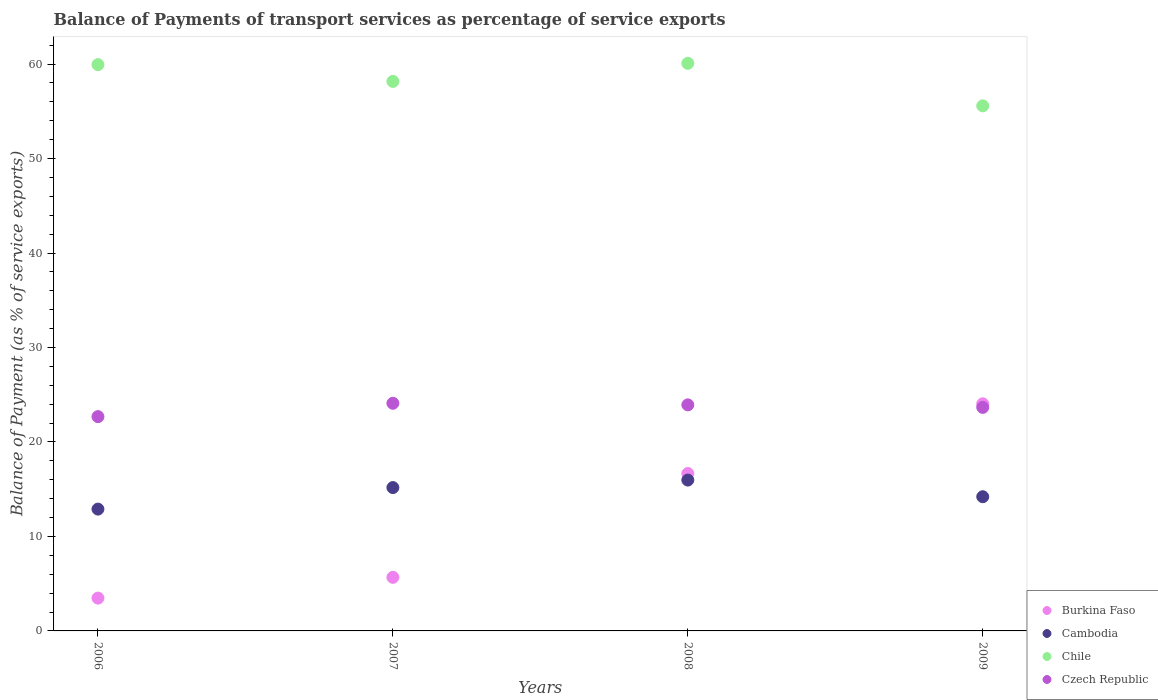What is the balance of payments of transport services in Czech Republic in 2008?
Offer a very short reply. 23.93. Across all years, what is the maximum balance of payments of transport services in Chile?
Provide a succinct answer. 60.08. Across all years, what is the minimum balance of payments of transport services in Burkina Faso?
Keep it short and to the point. 3.47. What is the total balance of payments of transport services in Czech Republic in the graph?
Give a very brief answer. 94.37. What is the difference between the balance of payments of transport services in Czech Republic in 2006 and that in 2007?
Give a very brief answer. -1.41. What is the difference between the balance of payments of transport services in Cambodia in 2006 and the balance of payments of transport services in Chile in 2008?
Keep it short and to the point. -47.19. What is the average balance of payments of transport services in Czech Republic per year?
Your response must be concise. 23.59. In the year 2009, what is the difference between the balance of payments of transport services in Czech Republic and balance of payments of transport services in Cambodia?
Your response must be concise. 9.46. In how many years, is the balance of payments of transport services in Chile greater than 56 %?
Your answer should be compact. 3. What is the ratio of the balance of payments of transport services in Burkina Faso in 2007 to that in 2008?
Keep it short and to the point. 0.34. Is the balance of payments of transport services in Chile in 2008 less than that in 2009?
Offer a very short reply. No. Is the difference between the balance of payments of transport services in Czech Republic in 2008 and 2009 greater than the difference between the balance of payments of transport services in Cambodia in 2008 and 2009?
Keep it short and to the point. No. What is the difference between the highest and the second highest balance of payments of transport services in Czech Republic?
Provide a succinct answer. 0.17. What is the difference between the highest and the lowest balance of payments of transport services in Czech Republic?
Your answer should be very brief. 1.41. In how many years, is the balance of payments of transport services in Burkina Faso greater than the average balance of payments of transport services in Burkina Faso taken over all years?
Offer a very short reply. 2. Is the sum of the balance of payments of transport services in Cambodia in 2007 and 2008 greater than the maximum balance of payments of transport services in Burkina Faso across all years?
Provide a short and direct response. Yes. Is it the case that in every year, the sum of the balance of payments of transport services in Chile and balance of payments of transport services in Czech Republic  is greater than the sum of balance of payments of transport services in Cambodia and balance of payments of transport services in Burkina Faso?
Provide a short and direct response. Yes. Does the balance of payments of transport services in Czech Republic monotonically increase over the years?
Offer a terse response. No. Is the balance of payments of transport services in Burkina Faso strictly greater than the balance of payments of transport services in Cambodia over the years?
Your answer should be very brief. No. Is the balance of payments of transport services in Burkina Faso strictly less than the balance of payments of transport services in Chile over the years?
Provide a short and direct response. Yes. How many dotlines are there?
Your answer should be compact. 4. Does the graph contain any zero values?
Provide a succinct answer. No. Does the graph contain grids?
Keep it short and to the point. No. How many legend labels are there?
Ensure brevity in your answer.  4. What is the title of the graph?
Ensure brevity in your answer.  Balance of Payments of transport services as percentage of service exports. Does "Djibouti" appear as one of the legend labels in the graph?
Make the answer very short. No. What is the label or title of the X-axis?
Offer a very short reply. Years. What is the label or title of the Y-axis?
Provide a succinct answer. Balance of Payment (as % of service exports). What is the Balance of Payment (as % of service exports) in Burkina Faso in 2006?
Your answer should be compact. 3.47. What is the Balance of Payment (as % of service exports) in Cambodia in 2006?
Your response must be concise. 12.89. What is the Balance of Payment (as % of service exports) in Chile in 2006?
Your response must be concise. 59.94. What is the Balance of Payment (as % of service exports) in Czech Republic in 2006?
Ensure brevity in your answer.  22.68. What is the Balance of Payment (as % of service exports) of Burkina Faso in 2007?
Your answer should be compact. 5.67. What is the Balance of Payment (as % of service exports) in Cambodia in 2007?
Your response must be concise. 15.17. What is the Balance of Payment (as % of service exports) of Chile in 2007?
Keep it short and to the point. 58.17. What is the Balance of Payment (as % of service exports) of Czech Republic in 2007?
Offer a terse response. 24.1. What is the Balance of Payment (as % of service exports) in Burkina Faso in 2008?
Your answer should be compact. 16.66. What is the Balance of Payment (as % of service exports) in Cambodia in 2008?
Keep it short and to the point. 15.97. What is the Balance of Payment (as % of service exports) in Chile in 2008?
Make the answer very short. 60.08. What is the Balance of Payment (as % of service exports) of Czech Republic in 2008?
Offer a terse response. 23.93. What is the Balance of Payment (as % of service exports) of Burkina Faso in 2009?
Provide a succinct answer. 24.04. What is the Balance of Payment (as % of service exports) in Cambodia in 2009?
Offer a very short reply. 14.21. What is the Balance of Payment (as % of service exports) of Chile in 2009?
Ensure brevity in your answer.  55.58. What is the Balance of Payment (as % of service exports) of Czech Republic in 2009?
Provide a short and direct response. 23.66. Across all years, what is the maximum Balance of Payment (as % of service exports) of Burkina Faso?
Ensure brevity in your answer.  24.04. Across all years, what is the maximum Balance of Payment (as % of service exports) of Cambodia?
Your answer should be compact. 15.97. Across all years, what is the maximum Balance of Payment (as % of service exports) in Chile?
Offer a very short reply. 60.08. Across all years, what is the maximum Balance of Payment (as % of service exports) of Czech Republic?
Offer a very short reply. 24.1. Across all years, what is the minimum Balance of Payment (as % of service exports) in Burkina Faso?
Offer a terse response. 3.47. Across all years, what is the minimum Balance of Payment (as % of service exports) of Cambodia?
Provide a short and direct response. 12.89. Across all years, what is the minimum Balance of Payment (as % of service exports) in Chile?
Your answer should be compact. 55.58. Across all years, what is the minimum Balance of Payment (as % of service exports) of Czech Republic?
Your response must be concise. 22.68. What is the total Balance of Payment (as % of service exports) in Burkina Faso in the graph?
Your response must be concise. 49.85. What is the total Balance of Payment (as % of service exports) in Cambodia in the graph?
Ensure brevity in your answer.  58.24. What is the total Balance of Payment (as % of service exports) in Chile in the graph?
Provide a short and direct response. 233.78. What is the total Balance of Payment (as % of service exports) of Czech Republic in the graph?
Your answer should be compact. 94.37. What is the difference between the Balance of Payment (as % of service exports) in Burkina Faso in 2006 and that in 2007?
Offer a terse response. -2.2. What is the difference between the Balance of Payment (as % of service exports) in Cambodia in 2006 and that in 2007?
Provide a short and direct response. -2.28. What is the difference between the Balance of Payment (as % of service exports) of Chile in 2006 and that in 2007?
Give a very brief answer. 1.78. What is the difference between the Balance of Payment (as % of service exports) of Czech Republic in 2006 and that in 2007?
Offer a terse response. -1.41. What is the difference between the Balance of Payment (as % of service exports) of Burkina Faso in 2006 and that in 2008?
Offer a very short reply. -13.19. What is the difference between the Balance of Payment (as % of service exports) of Cambodia in 2006 and that in 2008?
Ensure brevity in your answer.  -3.07. What is the difference between the Balance of Payment (as % of service exports) in Chile in 2006 and that in 2008?
Your response must be concise. -0.14. What is the difference between the Balance of Payment (as % of service exports) of Czech Republic in 2006 and that in 2008?
Your response must be concise. -1.24. What is the difference between the Balance of Payment (as % of service exports) of Burkina Faso in 2006 and that in 2009?
Ensure brevity in your answer.  -20.57. What is the difference between the Balance of Payment (as % of service exports) of Cambodia in 2006 and that in 2009?
Offer a terse response. -1.31. What is the difference between the Balance of Payment (as % of service exports) in Chile in 2006 and that in 2009?
Make the answer very short. 4.36. What is the difference between the Balance of Payment (as % of service exports) in Czech Republic in 2006 and that in 2009?
Offer a very short reply. -0.98. What is the difference between the Balance of Payment (as % of service exports) of Burkina Faso in 2007 and that in 2008?
Keep it short and to the point. -10.99. What is the difference between the Balance of Payment (as % of service exports) of Cambodia in 2007 and that in 2008?
Your answer should be very brief. -0.79. What is the difference between the Balance of Payment (as % of service exports) in Chile in 2007 and that in 2008?
Your answer should be compact. -1.92. What is the difference between the Balance of Payment (as % of service exports) in Czech Republic in 2007 and that in 2008?
Provide a succinct answer. 0.17. What is the difference between the Balance of Payment (as % of service exports) in Burkina Faso in 2007 and that in 2009?
Keep it short and to the point. -18.37. What is the difference between the Balance of Payment (as % of service exports) in Cambodia in 2007 and that in 2009?
Provide a short and direct response. 0.97. What is the difference between the Balance of Payment (as % of service exports) in Chile in 2007 and that in 2009?
Your answer should be compact. 2.59. What is the difference between the Balance of Payment (as % of service exports) in Czech Republic in 2007 and that in 2009?
Ensure brevity in your answer.  0.44. What is the difference between the Balance of Payment (as % of service exports) of Burkina Faso in 2008 and that in 2009?
Offer a terse response. -7.38. What is the difference between the Balance of Payment (as % of service exports) of Cambodia in 2008 and that in 2009?
Your answer should be very brief. 1.76. What is the difference between the Balance of Payment (as % of service exports) of Chile in 2008 and that in 2009?
Ensure brevity in your answer.  4.5. What is the difference between the Balance of Payment (as % of service exports) of Czech Republic in 2008 and that in 2009?
Ensure brevity in your answer.  0.27. What is the difference between the Balance of Payment (as % of service exports) in Burkina Faso in 2006 and the Balance of Payment (as % of service exports) in Cambodia in 2007?
Your response must be concise. -11.7. What is the difference between the Balance of Payment (as % of service exports) of Burkina Faso in 2006 and the Balance of Payment (as % of service exports) of Chile in 2007?
Provide a short and direct response. -54.69. What is the difference between the Balance of Payment (as % of service exports) in Burkina Faso in 2006 and the Balance of Payment (as % of service exports) in Czech Republic in 2007?
Ensure brevity in your answer.  -20.62. What is the difference between the Balance of Payment (as % of service exports) in Cambodia in 2006 and the Balance of Payment (as % of service exports) in Chile in 2007?
Keep it short and to the point. -45.27. What is the difference between the Balance of Payment (as % of service exports) in Cambodia in 2006 and the Balance of Payment (as % of service exports) in Czech Republic in 2007?
Keep it short and to the point. -11.2. What is the difference between the Balance of Payment (as % of service exports) in Chile in 2006 and the Balance of Payment (as % of service exports) in Czech Republic in 2007?
Make the answer very short. 35.85. What is the difference between the Balance of Payment (as % of service exports) in Burkina Faso in 2006 and the Balance of Payment (as % of service exports) in Cambodia in 2008?
Keep it short and to the point. -12.49. What is the difference between the Balance of Payment (as % of service exports) in Burkina Faso in 2006 and the Balance of Payment (as % of service exports) in Chile in 2008?
Ensure brevity in your answer.  -56.61. What is the difference between the Balance of Payment (as % of service exports) in Burkina Faso in 2006 and the Balance of Payment (as % of service exports) in Czech Republic in 2008?
Ensure brevity in your answer.  -20.46. What is the difference between the Balance of Payment (as % of service exports) in Cambodia in 2006 and the Balance of Payment (as % of service exports) in Chile in 2008?
Your answer should be very brief. -47.19. What is the difference between the Balance of Payment (as % of service exports) of Cambodia in 2006 and the Balance of Payment (as % of service exports) of Czech Republic in 2008?
Keep it short and to the point. -11.03. What is the difference between the Balance of Payment (as % of service exports) in Chile in 2006 and the Balance of Payment (as % of service exports) in Czech Republic in 2008?
Ensure brevity in your answer.  36.01. What is the difference between the Balance of Payment (as % of service exports) in Burkina Faso in 2006 and the Balance of Payment (as % of service exports) in Cambodia in 2009?
Keep it short and to the point. -10.73. What is the difference between the Balance of Payment (as % of service exports) of Burkina Faso in 2006 and the Balance of Payment (as % of service exports) of Chile in 2009?
Keep it short and to the point. -52.11. What is the difference between the Balance of Payment (as % of service exports) in Burkina Faso in 2006 and the Balance of Payment (as % of service exports) in Czech Republic in 2009?
Ensure brevity in your answer.  -20.19. What is the difference between the Balance of Payment (as % of service exports) of Cambodia in 2006 and the Balance of Payment (as % of service exports) of Chile in 2009?
Provide a short and direct response. -42.69. What is the difference between the Balance of Payment (as % of service exports) in Cambodia in 2006 and the Balance of Payment (as % of service exports) in Czech Republic in 2009?
Offer a terse response. -10.77. What is the difference between the Balance of Payment (as % of service exports) in Chile in 2006 and the Balance of Payment (as % of service exports) in Czech Republic in 2009?
Ensure brevity in your answer.  36.28. What is the difference between the Balance of Payment (as % of service exports) of Burkina Faso in 2007 and the Balance of Payment (as % of service exports) of Cambodia in 2008?
Keep it short and to the point. -10.29. What is the difference between the Balance of Payment (as % of service exports) of Burkina Faso in 2007 and the Balance of Payment (as % of service exports) of Chile in 2008?
Make the answer very short. -54.41. What is the difference between the Balance of Payment (as % of service exports) of Burkina Faso in 2007 and the Balance of Payment (as % of service exports) of Czech Republic in 2008?
Ensure brevity in your answer.  -18.26. What is the difference between the Balance of Payment (as % of service exports) in Cambodia in 2007 and the Balance of Payment (as % of service exports) in Chile in 2008?
Give a very brief answer. -44.91. What is the difference between the Balance of Payment (as % of service exports) of Cambodia in 2007 and the Balance of Payment (as % of service exports) of Czech Republic in 2008?
Your answer should be very brief. -8.76. What is the difference between the Balance of Payment (as % of service exports) of Chile in 2007 and the Balance of Payment (as % of service exports) of Czech Republic in 2008?
Your response must be concise. 34.24. What is the difference between the Balance of Payment (as % of service exports) in Burkina Faso in 2007 and the Balance of Payment (as % of service exports) in Cambodia in 2009?
Your answer should be compact. -8.53. What is the difference between the Balance of Payment (as % of service exports) in Burkina Faso in 2007 and the Balance of Payment (as % of service exports) in Chile in 2009?
Your response must be concise. -49.91. What is the difference between the Balance of Payment (as % of service exports) of Burkina Faso in 2007 and the Balance of Payment (as % of service exports) of Czech Republic in 2009?
Offer a very short reply. -17.99. What is the difference between the Balance of Payment (as % of service exports) of Cambodia in 2007 and the Balance of Payment (as % of service exports) of Chile in 2009?
Your answer should be very brief. -40.41. What is the difference between the Balance of Payment (as % of service exports) in Cambodia in 2007 and the Balance of Payment (as % of service exports) in Czech Republic in 2009?
Keep it short and to the point. -8.49. What is the difference between the Balance of Payment (as % of service exports) in Chile in 2007 and the Balance of Payment (as % of service exports) in Czech Republic in 2009?
Your answer should be very brief. 34.51. What is the difference between the Balance of Payment (as % of service exports) in Burkina Faso in 2008 and the Balance of Payment (as % of service exports) in Cambodia in 2009?
Your answer should be compact. 2.46. What is the difference between the Balance of Payment (as % of service exports) in Burkina Faso in 2008 and the Balance of Payment (as % of service exports) in Chile in 2009?
Your response must be concise. -38.92. What is the difference between the Balance of Payment (as % of service exports) in Burkina Faso in 2008 and the Balance of Payment (as % of service exports) in Czech Republic in 2009?
Your answer should be very brief. -7. What is the difference between the Balance of Payment (as % of service exports) in Cambodia in 2008 and the Balance of Payment (as % of service exports) in Chile in 2009?
Offer a terse response. -39.61. What is the difference between the Balance of Payment (as % of service exports) in Cambodia in 2008 and the Balance of Payment (as % of service exports) in Czech Republic in 2009?
Make the answer very short. -7.69. What is the difference between the Balance of Payment (as % of service exports) of Chile in 2008 and the Balance of Payment (as % of service exports) of Czech Republic in 2009?
Offer a very short reply. 36.42. What is the average Balance of Payment (as % of service exports) in Burkina Faso per year?
Ensure brevity in your answer.  12.46. What is the average Balance of Payment (as % of service exports) in Cambodia per year?
Your response must be concise. 14.56. What is the average Balance of Payment (as % of service exports) in Chile per year?
Your answer should be very brief. 58.44. What is the average Balance of Payment (as % of service exports) in Czech Republic per year?
Your answer should be very brief. 23.59. In the year 2006, what is the difference between the Balance of Payment (as % of service exports) in Burkina Faso and Balance of Payment (as % of service exports) in Cambodia?
Ensure brevity in your answer.  -9.42. In the year 2006, what is the difference between the Balance of Payment (as % of service exports) in Burkina Faso and Balance of Payment (as % of service exports) in Chile?
Give a very brief answer. -56.47. In the year 2006, what is the difference between the Balance of Payment (as % of service exports) in Burkina Faso and Balance of Payment (as % of service exports) in Czech Republic?
Your response must be concise. -19.21. In the year 2006, what is the difference between the Balance of Payment (as % of service exports) in Cambodia and Balance of Payment (as % of service exports) in Chile?
Provide a succinct answer. -47.05. In the year 2006, what is the difference between the Balance of Payment (as % of service exports) of Cambodia and Balance of Payment (as % of service exports) of Czech Republic?
Make the answer very short. -9.79. In the year 2006, what is the difference between the Balance of Payment (as % of service exports) of Chile and Balance of Payment (as % of service exports) of Czech Republic?
Ensure brevity in your answer.  37.26. In the year 2007, what is the difference between the Balance of Payment (as % of service exports) in Burkina Faso and Balance of Payment (as % of service exports) in Cambodia?
Provide a succinct answer. -9.5. In the year 2007, what is the difference between the Balance of Payment (as % of service exports) in Burkina Faso and Balance of Payment (as % of service exports) in Chile?
Your answer should be compact. -52.49. In the year 2007, what is the difference between the Balance of Payment (as % of service exports) in Burkina Faso and Balance of Payment (as % of service exports) in Czech Republic?
Your response must be concise. -18.42. In the year 2007, what is the difference between the Balance of Payment (as % of service exports) of Cambodia and Balance of Payment (as % of service exports) of Chile?
Give a very brief answer. -42.99. In the year 2007, what is the difference between the Balance of Payment (as % of service exports) in Cambodia and Balance of Payment (as % of service exports) in Czech Republic?
Provide a succinct answer. -8.92. In the year 2007, what is the difference between the Balance of Payment (as % of service exports) in Chile and Balance of Payment (as % of service exports) in Czech Republic?
Offer a very short reply. 34.07. In the year 2008, what is the difference between the Balance of Payment (as % of service exports) of Burkina Faso and Balance of Payment (as % of service exports) of Cambodia?
Offer a terse response. 0.69. In the year 2008, what is the difference between the Balance of Payment (as % of service exports) of Burkina Faso and Balance of Payment (as % of service exports) of Chile?
Provide a short and direct response. -43.42. In the year 2008, what is the difference between the Balance of Payment (as % of service exports) of Burkina Faso and Balance of Payment (as % of service exports) of Czech Republic?
Offer a very short reply. -7.27. In the year 2008, what is the difference between the Balance of Payment (as % of service exports) of Cambodia and Balance of Payment (as % of service exports) of Chile?
Make the answer very short. -44.12. In the year 2008, what is the difference between the Balance of Payment (as % of service exports) of Cambodia and Balance of Payment (as % of service exports) of Czech Republic?
Provide a succinct answer. -7.96. In the year 2008, what is the difference between the Balance of Payment (as % of service exports) in Chile and Balance of Payment (as % of service exports) in Czech Republic?
Keep it short and to the point. 36.15. In the year 2009, what is the difference between the Balance of Payment (as % of service exports) of Burkina Faso and Balance of Payment (as % of service exports) of Cambodia?
Keep it short and to the point. 9.83. In the year 2009, what is the difference between the Balance of Payment (as % of service exports) in Burkina Faso and Balance of Payment (as % of service exports) in Chile?
Offer a terse response. -31.54. In the year 2009, what is the difference between the Balance of Payment (as % of service exports) in Burkina Faso and Balance of Payment (as % of service exports) in Czech Republic?
Offer a terse response. 0.38. In the year 2009, what is the difference between the Balance of Payment (as % of service exports) of Cambodia and Balance of Payment (as % of service exports) of Chile?
Offer a terse response. -41.38. In the year 2009, what is the difference between the Balance of Payment (as % of service exports) in Cambodia and Balance of Payment (as % of service exports) in Czech Republic?
Your answer should be very brief. -9.46. In the year 2009, what is the difference between the Balance of Payment (as % of service exports) in Chile and Balance of Payment (as % of service exports) in Czech Republic?
Offer a very short reply. 31.92. What is the ratio of the Balance of Payment (as % of service exports) of Burkina Faso in 2006 to that in 2007?
Make the answer very short. 0.61. What is the ratio of the Balance of Payment (as % of service exports) in Cambodia in 2006 to that in 2007?
Provide a succinct answer. 0.85. What is the ratio of the Balance of Payment (as % of service exports) of Chile in 2006 to that in 2007?
Ensure brevity in your answer.  1.03. What is the ratio of the Balance of Payment (as % of service exports) of Czech Republic in 2006 to that in 2007?
Provide a succinct answer. 0.94. What is the ratio of the Balance of Payment (as % of service exports) of Burkina Faso in 2006 to that in 2008?
Your response must be concise. 0.21. What is the ratio of the Balance of Payment (as % of service exports) in Cambodia in 2006 to that in 2008?
Give a very brief answer. 0.81. What is the ratio of the Balance of Payment (as % of service exports) of Chile in 2006 to that in 2008?
Offer a terse response. 1. What is the ratio of the Balance of Payment (as % of service exports) of Czech Republic in 2006 to that in 2008?
Offer a very short reply. 0.95. What is the ratio of the Balance of Payment (as % of service exports) of Burkina Faso in 2006 to that in 2009?
Your answer should be compact. 0.14. What is the ratio of the Balance of Payment (as % of service exports) in Cambodia in 2006 to that in 2009?
Provide a short and direct response. 0.91. What is the ratio of the Balance of Payment (as % of service exports) in Chile in 2006 to that in 2009?
Your answer should be very brief. 1.08. What is the ratio of the Balance of Payment (as % of service exports) of Czech Republic in 2006 to that in 2009?
Keep it short and to the point. 0.96. What is the ratio of the Balance of Payment (as % of service exports) in Burkina Faso in 2007 to that in 2008?
Ensure brevity in your answer.  0.34. What is the ratio of the Balance of Payment (as % of service exports) in Cambodia in 2007 to that in 2008?
Offer a terse response. 0.95. What is the ratio of the Balance of Payment (as % of service exports) of Chile in 2007 to that in 2008?
Provide a short and direct response. 0.97. What is the ratio of the Balance of Payment (as % of service exports) in Czech Republic in 2007 to that in 2008?
Offer a very short reply. 1.01. What is the ratio of the Balance of Payment (as % of service exports) in Burkina Faso in 2007 to that in 2009?
Your answer should be very brief. 0.24. What is the ratio of the Balance of Payment (as % of service exports) of Cambodia in 2007 to that in 2009?
Your answer should be very brief. 1.07. What is the ratio of the Balance of Payment (as % of service exports) in Chile in 2007 to that in 2009?
Your answer should be compact. 1.05. What is the ratio of the Balance of Payment (as % of service exports) of Czech Republic in 2007 to that in 2009?
Give a very brief answer. 1.02. What is the ratio of the Balance of Payment (as % of service exports) of Burkina Faso in 2008 to that in 2009?
Your answer should be very brief. 0.69. What is the ratio of the Balance of Payment (as % of service exports) of Cambodia in 2008 to that in 2009?
Keep it short and to the point. 1.12. What is the ratio of the Balance of Payment (as % of service exports) of Chile in 2008 to that in 2009?
Make the answer very short. 1.08. What is the ratio of the Balance of Payment (as % of service exports) of Czech Republic in 2008 to that in 2009?
Your answer should be very brief. 1.01. What is the difference between the highest and the second highest Balance of Payment (as % of service exports) in Burkina Faso?
Your answer should be very brief. 7.38. What is the difference between the highest and the second highest Balance of Payment (as % of service exports) in Cambodia?
Make the answer very short. 0.79. What is the difference between the highest and the second highest Balance of Payment (as % of service exports) in Chile?
Offer a very short reply. 0.14. What is the difference between the highest and the second highest Balance of Payment (as % of service exports) of Czech Republic?
Your answer should be very brief. 0.17. What is the difference between the highest and the lowest Balance of Payment (as % of service exports) in Burkina Faso?
Make the answer very short. 20.57. What is the difference between the highest and the lowest Balance of Payment (as % of service exports) of Cambodia?
Keep it short and to the point. 3.07. What is the difference between the highest and the lowest Balance of Payment (as % of service exports) in Chile?
Ensure brevity in your answer.  4.5. What is the difference between the highest and the lowest Balance of Payment (as % of service exports) of Czech Republic?
Your response must be concise. 1.41. 